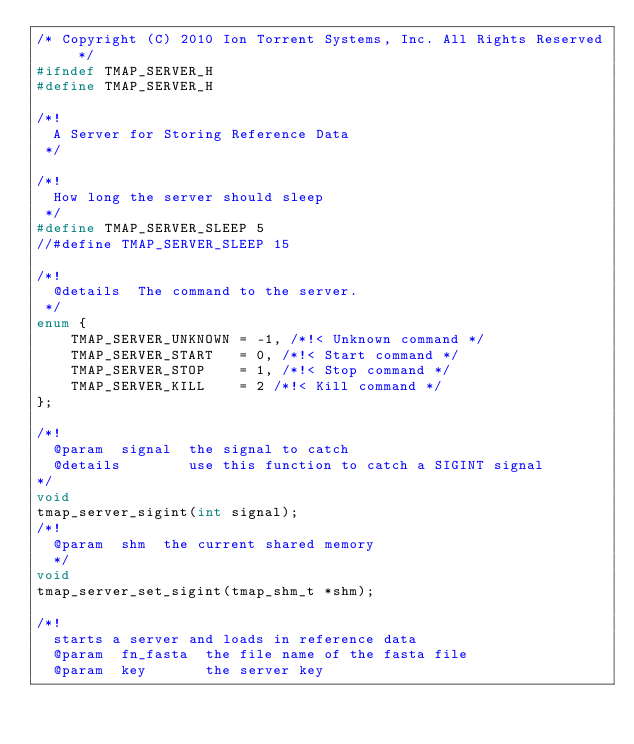<code> <loc_0><loc_0><loc_500><loc_500><_C_>/* Copyright (C) 2010 Ion Torrent Systems, Inc. All Rights Reserved */
#ifndef TMAP_SERVER_H
#define TMAP_SERVER_H

/*! 
  A Server for Storing Reference Data
 */

/*! 
  How long the server should sleep
 */
#define TMAP_SERVER_SLEEP 5
//#define TMAP_SERVER_SLEEP 15

/*! 
  @details  The command to the server.
 */
enum {
    TMAP_SERVER_UNKNOWN = -1, /*!< Unknown command */
    TMAP_SERVER_START   = 0, /*!< Start command */
    TMAP_SERVER_STOP    = 1, /*!< Stop command */
    TMAP_SERVER_KILL    = 2 /*!< Kill command */
};

/*! 
  @param  signal  the signal to catch
  @details        use this function to catch a SIGINT signal
*/
void
tmap_server_sigint(int signal);
/*! 
  @param  shm  the current shared memory
  */
void
tmap_server_set_sigint(tmap_shm_t *shm);

/*! 
  starts a server and loads in reference data
  @param  fn_fasta  the file name of the fasta file
  @param  key       the server key</code> 